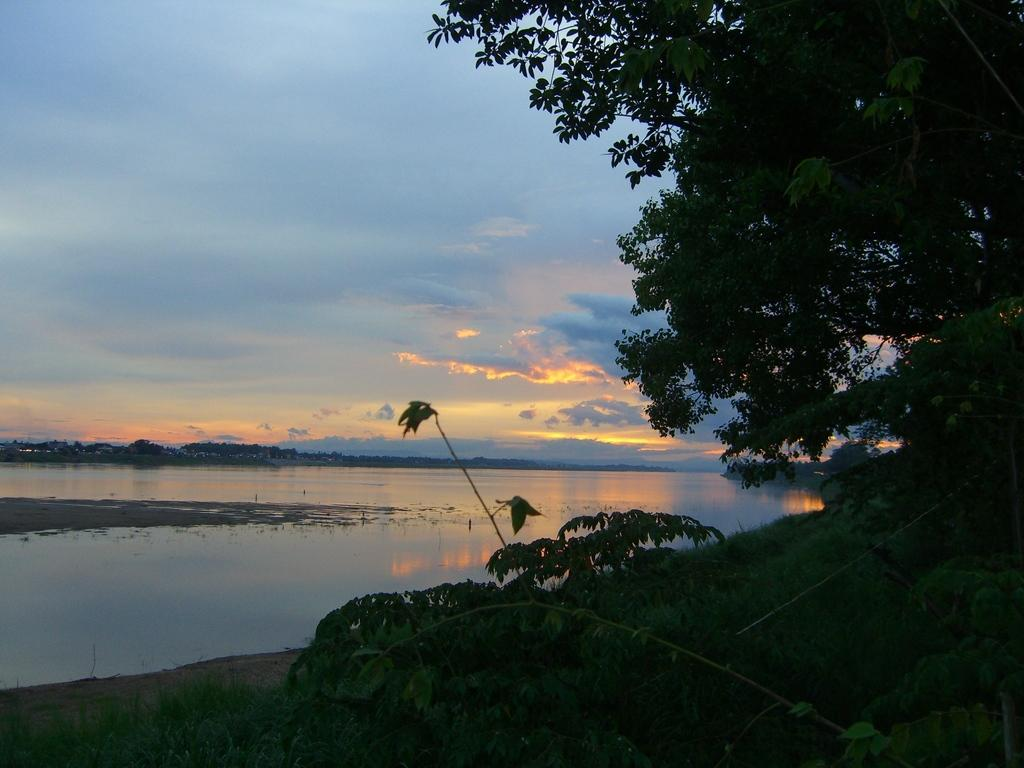What type of vegetation can be seen in the image? There are trees and grass in the image. What else can be found on the ground in the image? There are leaves in the image. What is visible in the background of the image? The sky is visible in the background of the image. What can be seen in the sky? Clouds are present in the sky. Is there any water visible in the image? Yes, there is water visible in the image. What color is the crayon used to draw the basket in the image? There is no crayon or basket present in the image. 